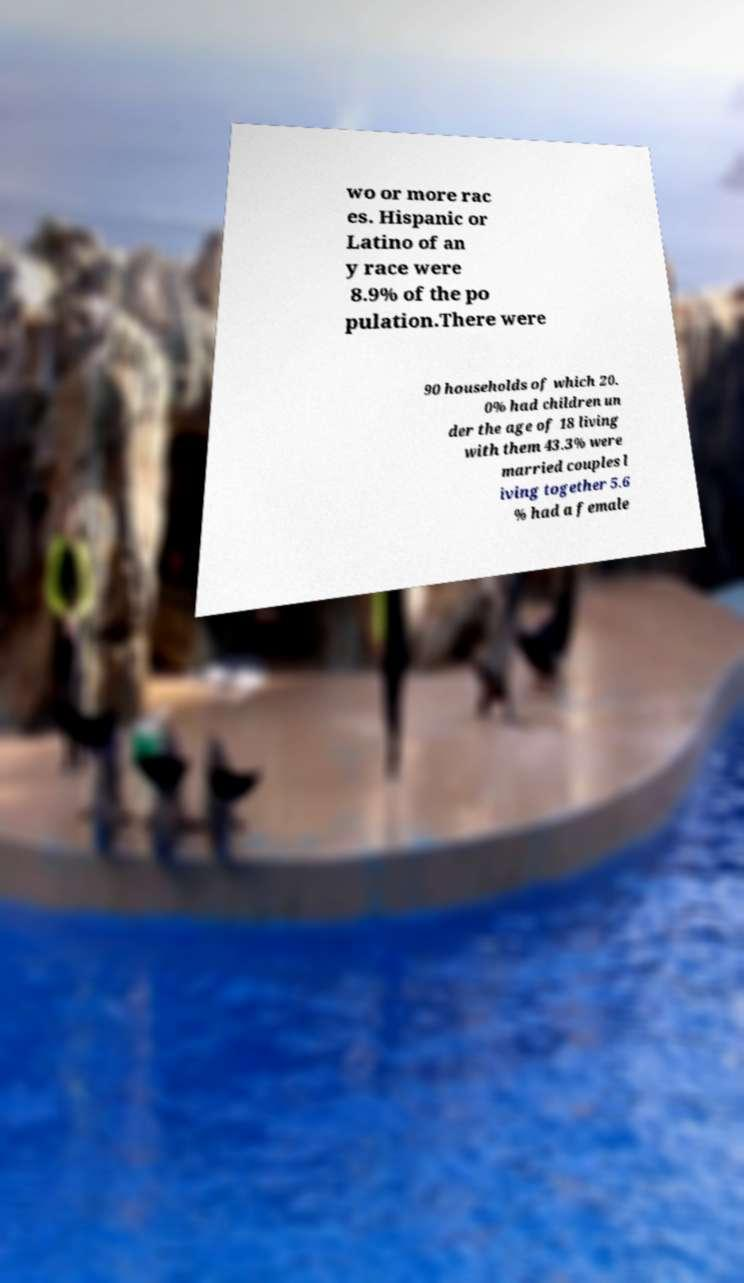What messages or text are displayed in this image? I need them in a readable, typed format. wo or more rac es. Hispanic or Latino of an y race were 8.9% of the po pulation.There were 90 households of which 20. 0% had children un der the age of 18 living with them 43.3% were married couples l iving together 5.6 % had a female 